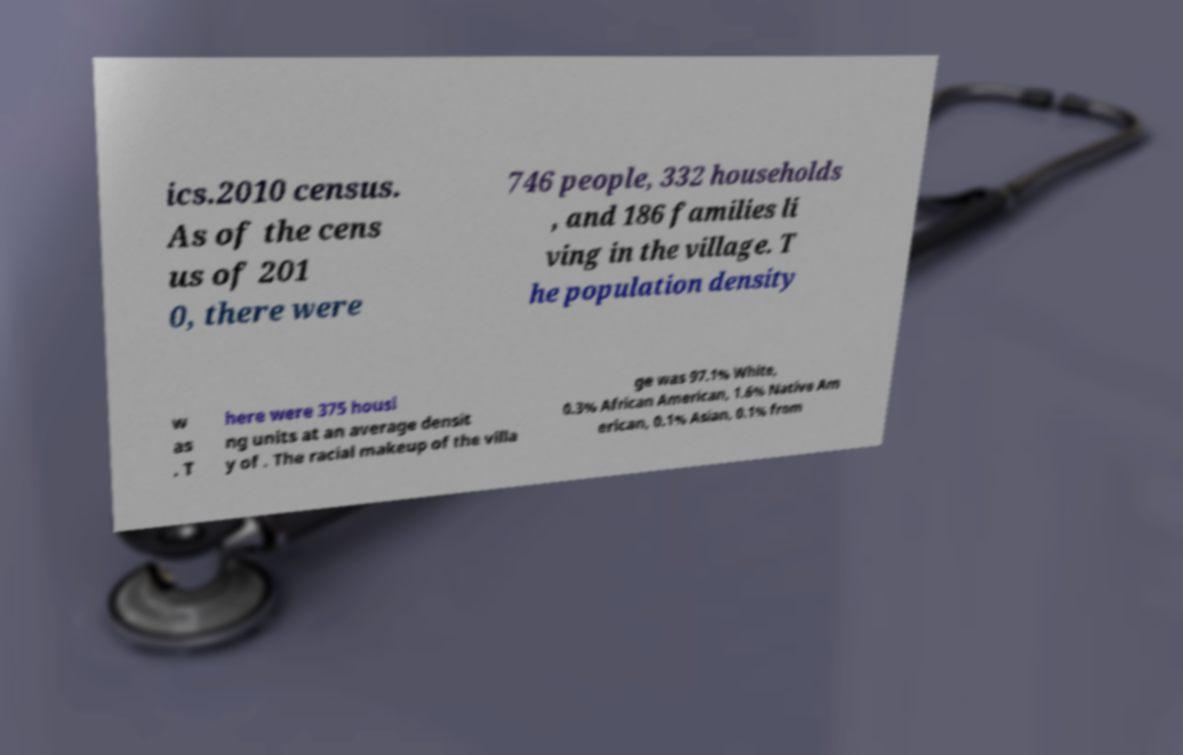I need the written content from this picture converted into text. Can you do that? ics.2010 census. As of the cens us of 201 0, there were 746 people, 332 households , and 186 families li ving in the village. T he population density w as . T here were 375 housi ng units at an average densit y of . The racial makeup of the villa ge was 97.1% White, 0.3% African American, 1.6% Native Am erican, 0.1% Asian, 0.1% from 